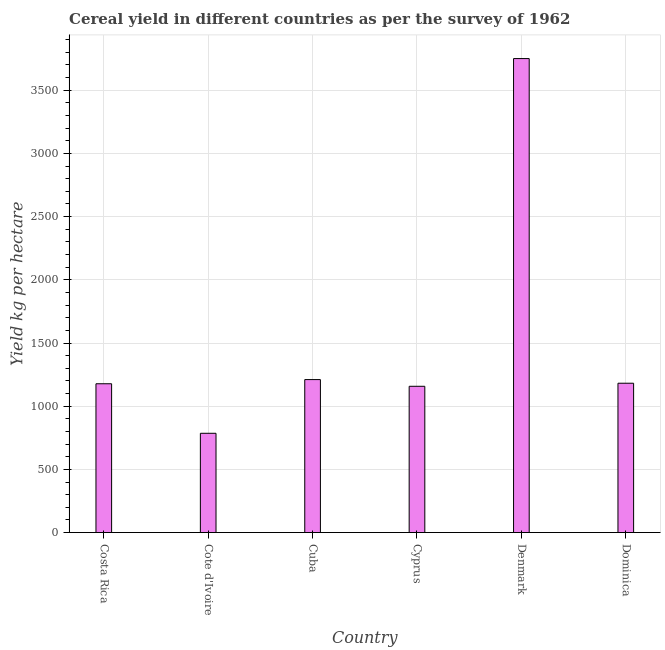Does the graph contain grids?
Your answer should be very brief. Yes. What is the title of the graph?
Your response must be concise. Cereal yield in different countries as per the survey of 1962. What is the label or title of the X-axis?
Make the answer very short. Country. What is the label or title of the Y-axis?
Your response must be concise. Yield kg per hectare. What is the cereal yield in Costa Rica?
Offer a terse response. 1177.62. Across all countries, what is the maximum cereal yield?
Provide a succinct answer. 3750.59. Across all countries, what is the minimum cereal yield?
Give a very brief answer. 785.71. In which country was the cereal yield maximum?
Give a very brief answer. Denmark. In which country was the cereal yield minimum?
Offer a terse response. Cote d'Ivoire. What is the sum of the cereal yield?
Provide a short and direct response. 9264.02. What is the difference between the cereal yield in Cote d'Ivoire and Cyprus?
Keep it short and to the point. -371.9. What is the average cereal yield per country?
Offer a very short reply. 1544. What is the median cereal yield?
Your answer should be very brief. 1179.72. What is the ratio of the cereal yield in Cyprus to that in Dominica?
Your response must be concise. 0.98. Is the difference between the cereal yield in Costa Rica and Denmark greater than the difference between any two countries?
Ensure brevity in your answer.  No. What is the difference between the highest and the second highest cereal yield?
Your response must be concise. 2539.94. What is the difference between the highest and the lowest cereal yield?
Provide a succinct answer. 2964.88. How many bars are there?
Your answer should be very brief. 6. Are all the bars in the graph horizontal?
Offer a terse response. No. How many countries are there in the graph?
Give a very brief answer. 6. What is the difference between two consecutive major ticks on the Y-axis?
Your answer should be very brief. 500. What is the Yield kg per hectare in Costa Rica?
Offer a very short reply. 1177.62. What is the Yield kg per hectare of Cote d'Ivoire?
Make the answer very short. 785.71. What is the Yield kg per hectare of Cuba?
Give a very brief answer. 1210.66. What is the Yield kg per hectare of Cyprus?
Your response must be concise. 1157.61. What is the Yield kg per hectare of Denmark?
Your response must be concise. 3750.59. What is the Yield kg per hectare in Dominica?
Ensure brevity in your answer.  1181.82. What is the difference between the Yield kg per hectare in Costa Rica and Cote d'Ivoire?
Your answer should be compact. 391.91. What is the difference between the Yield kg per hectare in Costa Rica and Cuba?
Ensure brevity in your answer.  -33.03. What is the difference between the Yield kg per hectare in Costa Rica and Cyprus?
Give a very brief answer. 20.01. What is the difference between the Yield kg per hectare in Costa Rica and Denmark?
Make the answer very short. -2572.97. What is the difference between the Yield kg per hectare in Costa Rica and Dominica?
Your answer should be compact. -4.19. What is the difference between the Yield kg per hectare in Cote d'Ivoire and Cuba?
Your response must be concise. -424.94. What is the difference between the Yield kg per hectare in Cote d'Ivoire and Cyprus?
Provide a succinct answer. -371.9. What is the difference between the Yield kg per hectare in Cote d'Ivoire and Denmark?
Your answer should be very brief. -2964.88. What is the difference between the Yield kg per hectare in Cote d'Ivoire and Dominica?
Your answer should be compact. -396.1. What is the difference between the Yield kg per hectare in Cuba and Cyprus?
Provide a succinct answer. 53.04. What is the difference between the Yield kg per hectare in Cuba and Denmark?
Your answer should be compact. -2539.94. What is the difference between the Yield kg per hectare in Cuba and Dominica?
Give a very brief answer. 28.84. What is the difference between the Yield kg per hectare in Cyprus and Denmark?
Provide a short and direct response. -2592.98. What is the difference between the Yield kg per hectare in Cyprus and Dominica?
Ensure brevity in your answer.  -24.21. What is the difference between the Yield kg per hectare in Denmark and Dominica?
Give a very brief answer. 2568.78. What is the ratio of the Yield kg per hectare in Costa Rica to that in Cote d'Ivoire?
Your answer should be compact. 1.5. What is the ratio of the Yield kg per hectare in Costa Rica to that in Cuba?
Your response must be concise. 0.97. What is the ratio of the Yield kg per hectare in Costa Rica to that in Cyprus?
Make the answer very short. 1.02. What is the ratio of the Yield kg per hectare in Costa Rica to that in Denmark?
Offer a very short reply. 0.31. What is the ratio of the Yield kg per hectare in Cote d'Ivoire to that in Cuba?
Keep it short and to the point. 0.65. What is the ratio of the Yield kg per hectare in Cote d'Ivoire to that in Cyprus?
Keep it short and to the point. 0.68. What is the ratio of the Yield kg per hectare in Cote d'Ivoire to that in Denmark?
Provide a short and direct response. 0.21. What is the ratio of the Yield kg per hectare in Cote d'Ivoire to that in Dominica?
Make the answer very short. 0.67. What is the ratio of the Yield kg per hectare in Cuba to that in Cyprus?
Provide a succinct answer. 1.05. What is the ratio of the Yield kg per hectare in Cuba to that in Denmark?
Provide a short and direct response. 0.32. What is the ratio of the Yield kg per hectare in Cyprus to that in Denmark?
Your answer should be compact. 0.31. What is the ratio of the Yield kg per hectare in Denmark to that in Dominica?
Your answer should be very brief. 3.17. 